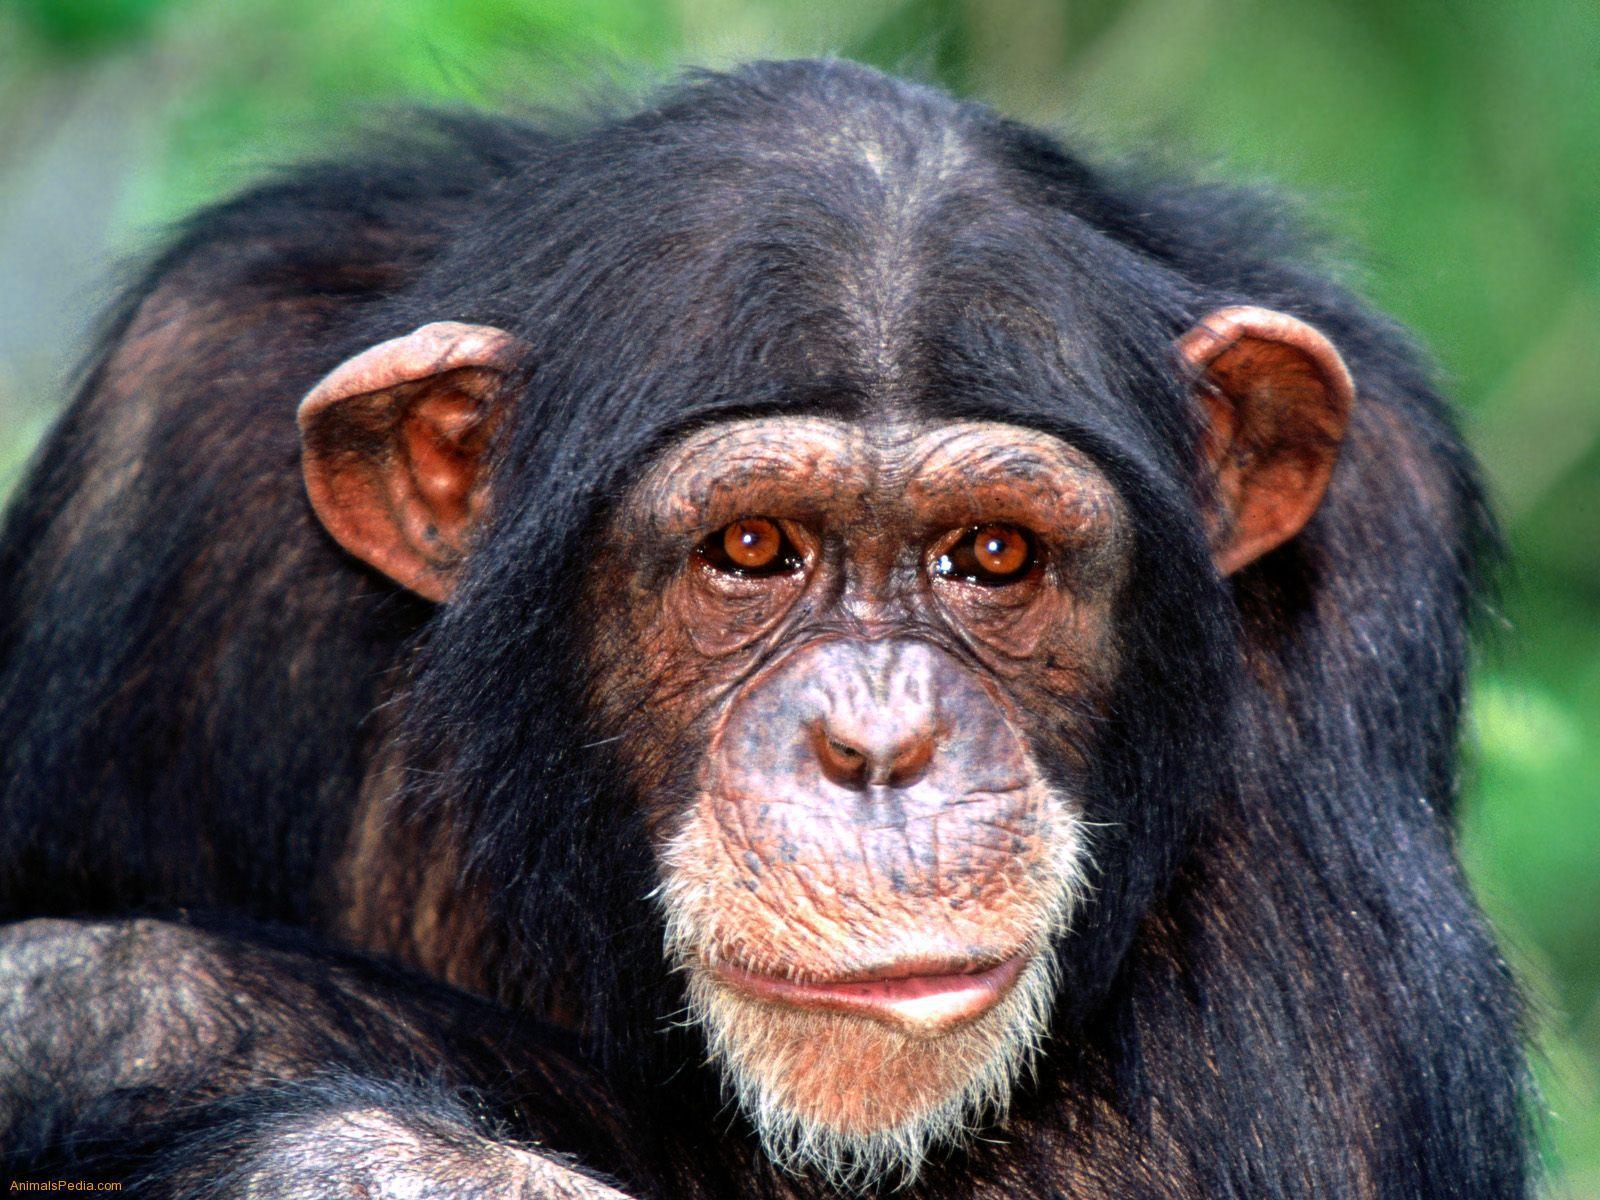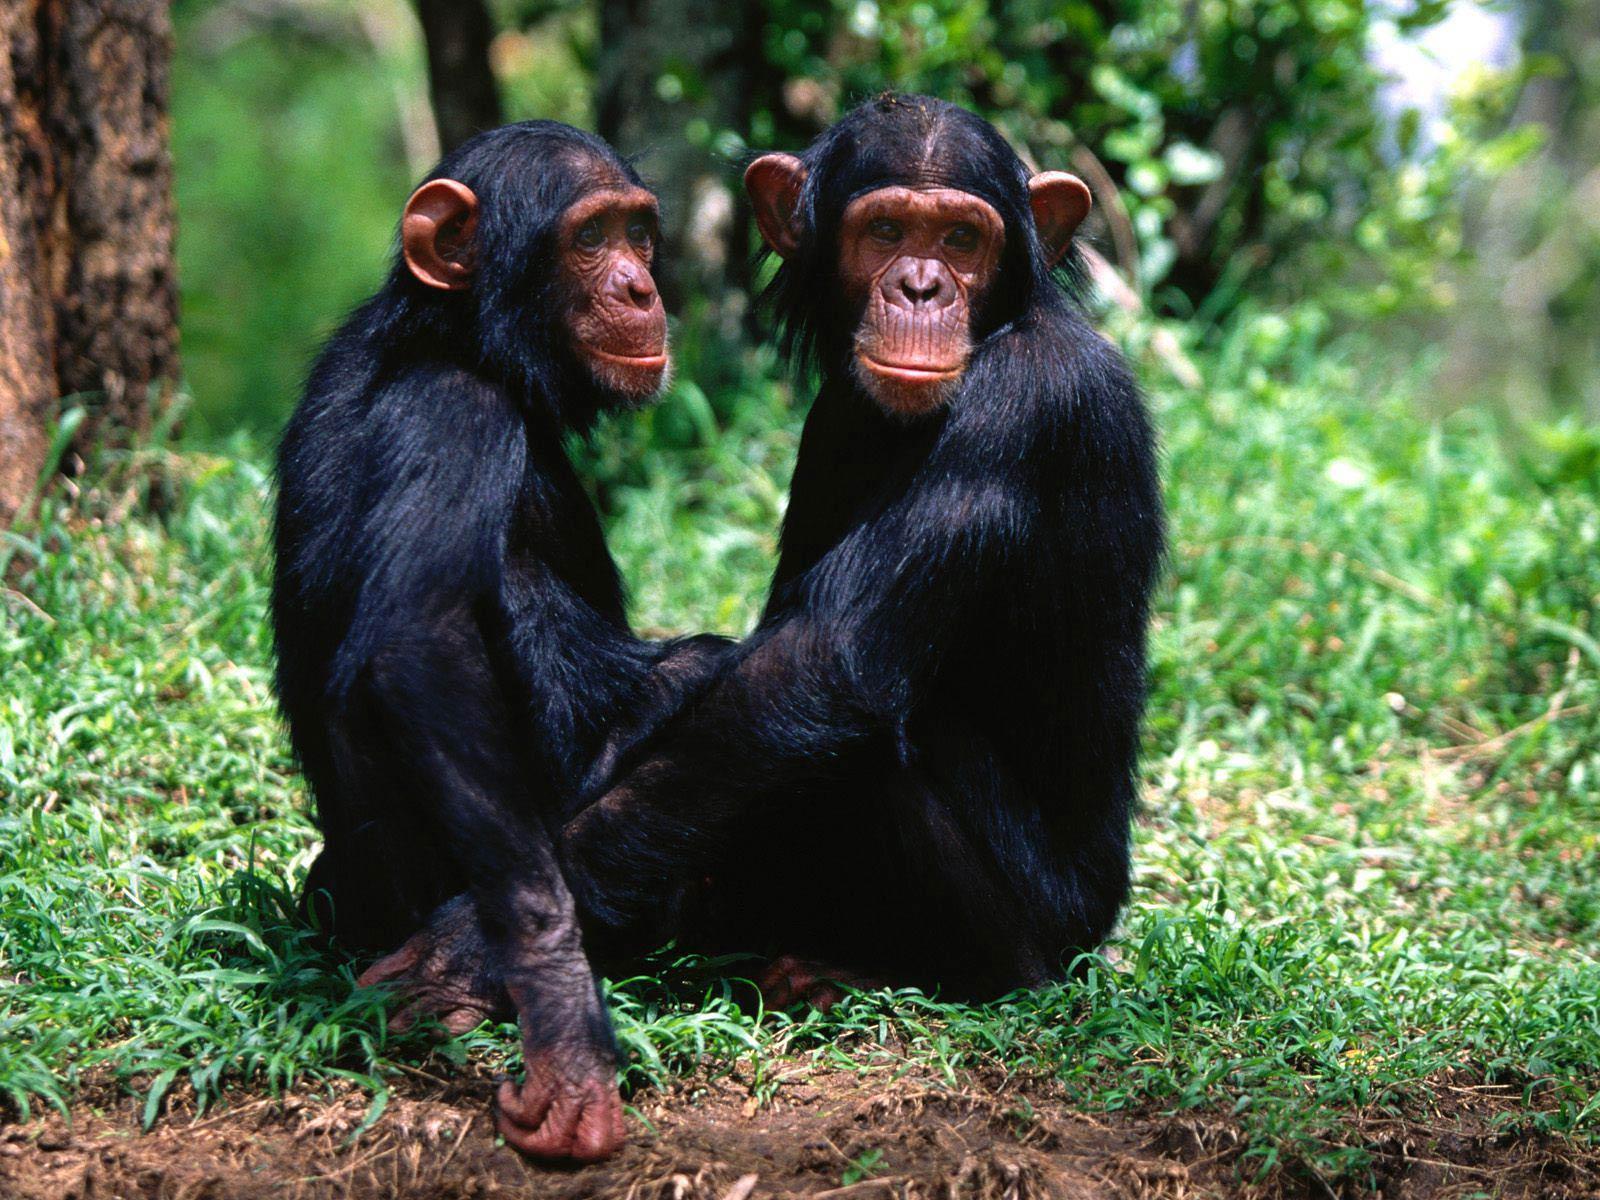The first image is the image on the left, the second image is the image on the right. Analyze the images presented: Is the assertion "In one of the images, a young chimp places something in its mouth." valid? Answer yes or no. No. The first image is the image on the left, the second image is the image on the right. Given the left and right images, does the statement "A small monkey eats leaves." hold true? Answer yes or no. No. 